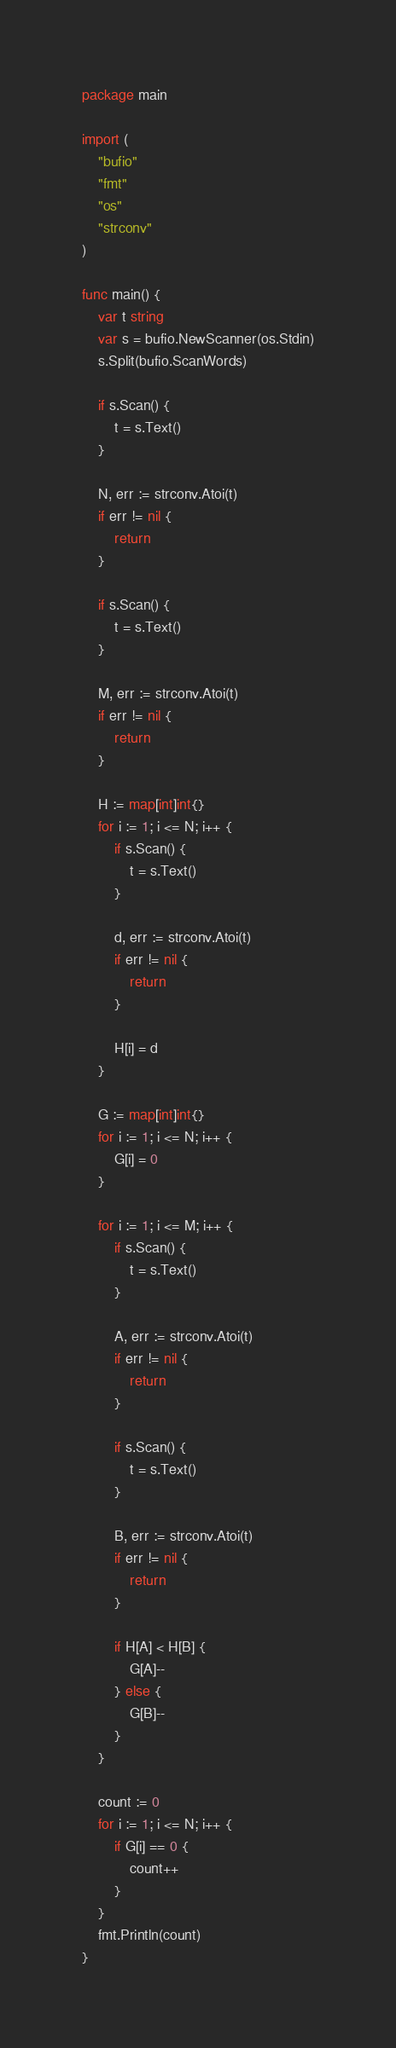<code> <loc_0><loc_0><loc_500><loc_500><_Go_>package main

import (
	"bufio"
	"fmt"
	"os"
	"strconv"
)

func main() {
	var t string
	var s = bufio.NewScanner(os.Stdin)
	s.Split(bufio.ScanWords)

	if s.Scan() {
		t = s.Text()
	}

	N, err := strconv.Atoi(t)
	if err != nil {
		return
	}

	if s.Scan() {
		t = s.Text()
	}

	M, err := strconv.Atoi(t)
	if err != nil {
		return
	}

	H := map[int]int{}
	for i := 1; i <= N; i++ {
		if s.Scan() {
			t = s.Text()
		}

		d, err := strconv.Atoi(t)
		if err != nil {
			return
		}

		H[i] = d
	}

	G := map[int]int{}
	for i := 1; i <= N; i++ {
		G[i] = 0
	}

	for i := 1; i <= M; i++ {
		if s.Scan() {
			t = s.Text()
		}

		A, err := strconv.Atoi(t)
		if err != nil {
			return
		}

		if s.Scan() {
			t = s.Text()
		}

		B, err := strconv.Atoi(t)
		if err != nil {
			return
		}

		if H[A] < H[B] {
			G[A]--
		} else {
			G[B]--
		}
	}

	count := 0
	for i := 1; i <= N; i++ {
		if G[i] == 0 {
			count++
		}
	}
	fmt.Println(count)
}
</code> 